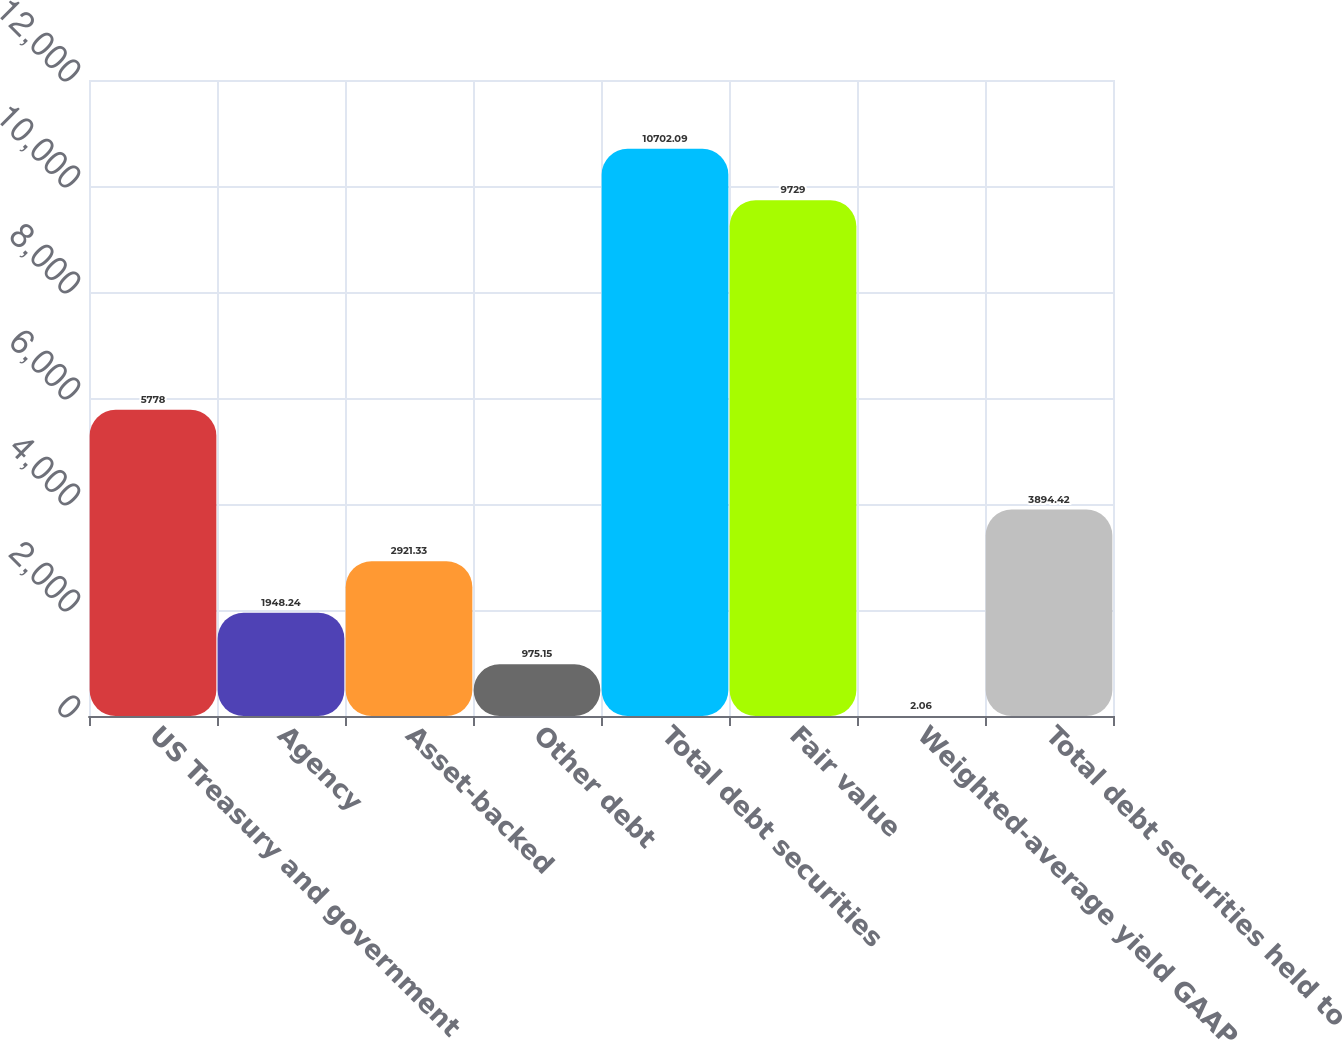<chart> <loc_0><loc_0><loc_500><loc_500><bar_chart><fcel>US Treasury and government<fcel>Agency<fcel>Asset-backed<fcel>Other debt<fcel>Total debt securities<fcel>Fair value<fcel>Weighted-average yield GAAP<fcel>Total debt securities held to<nl><fcel>5778<fcel>1948.24<fcel>2921.33<fcel>975.15<fcel>10702.1<fcel>9729<fcel>2.06<fcel>3894.42<nl></chart> 